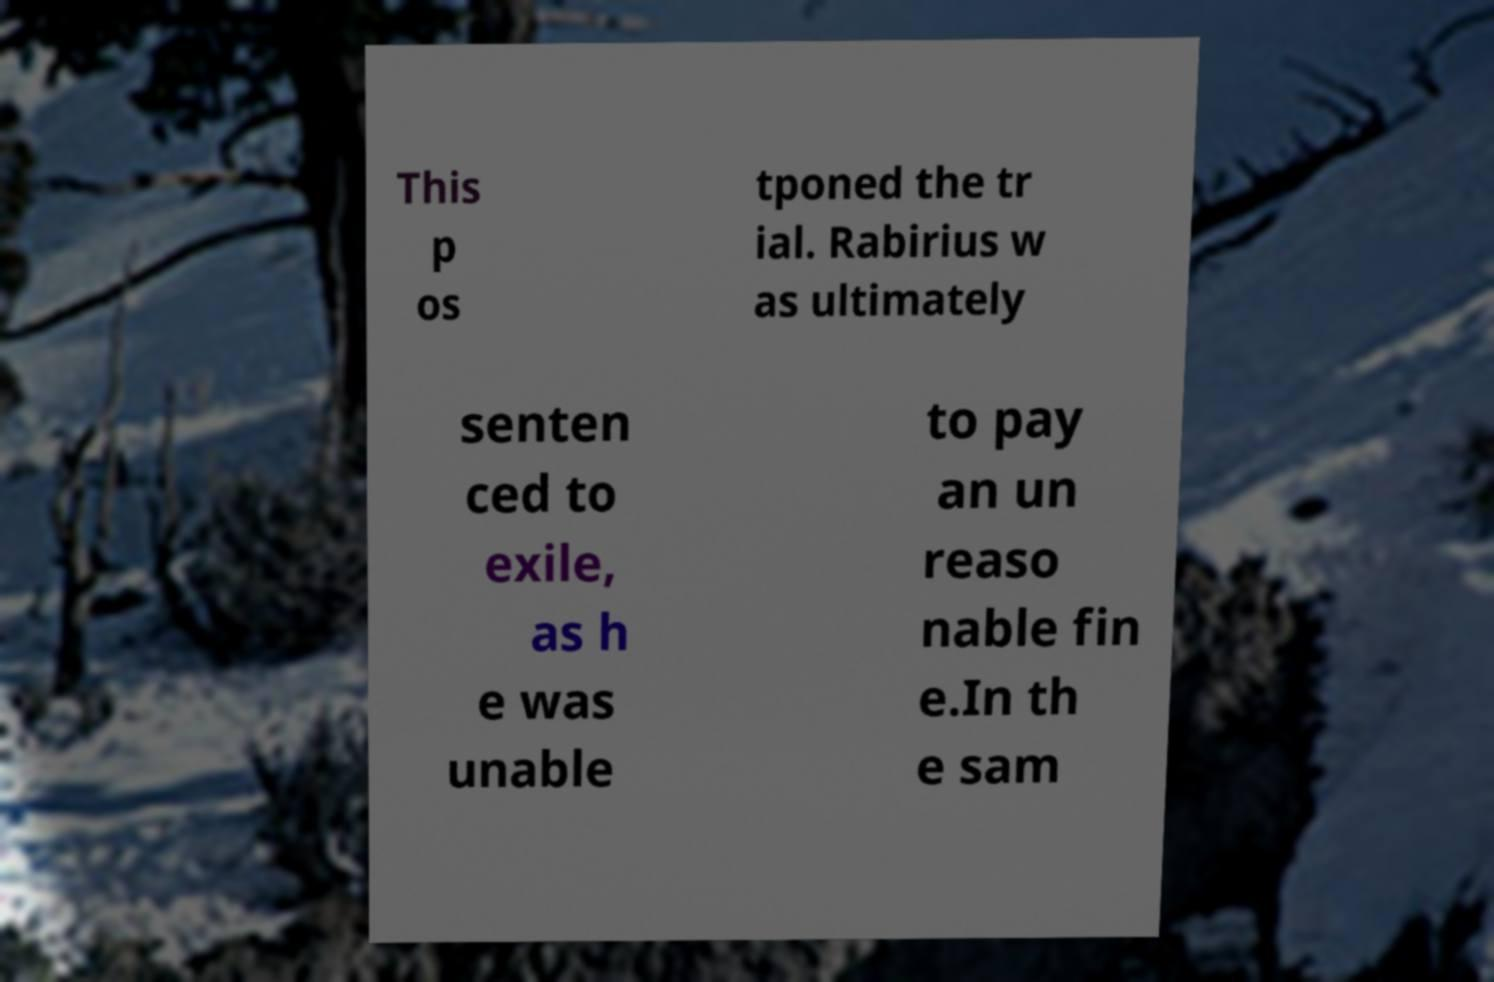Could you extract and type out the text from this image? This p os tponed the tr ial. Rabirius w as ultimately senten ced to exile, as h e was unable to pay an un reaso nable fin e.In th e sam 